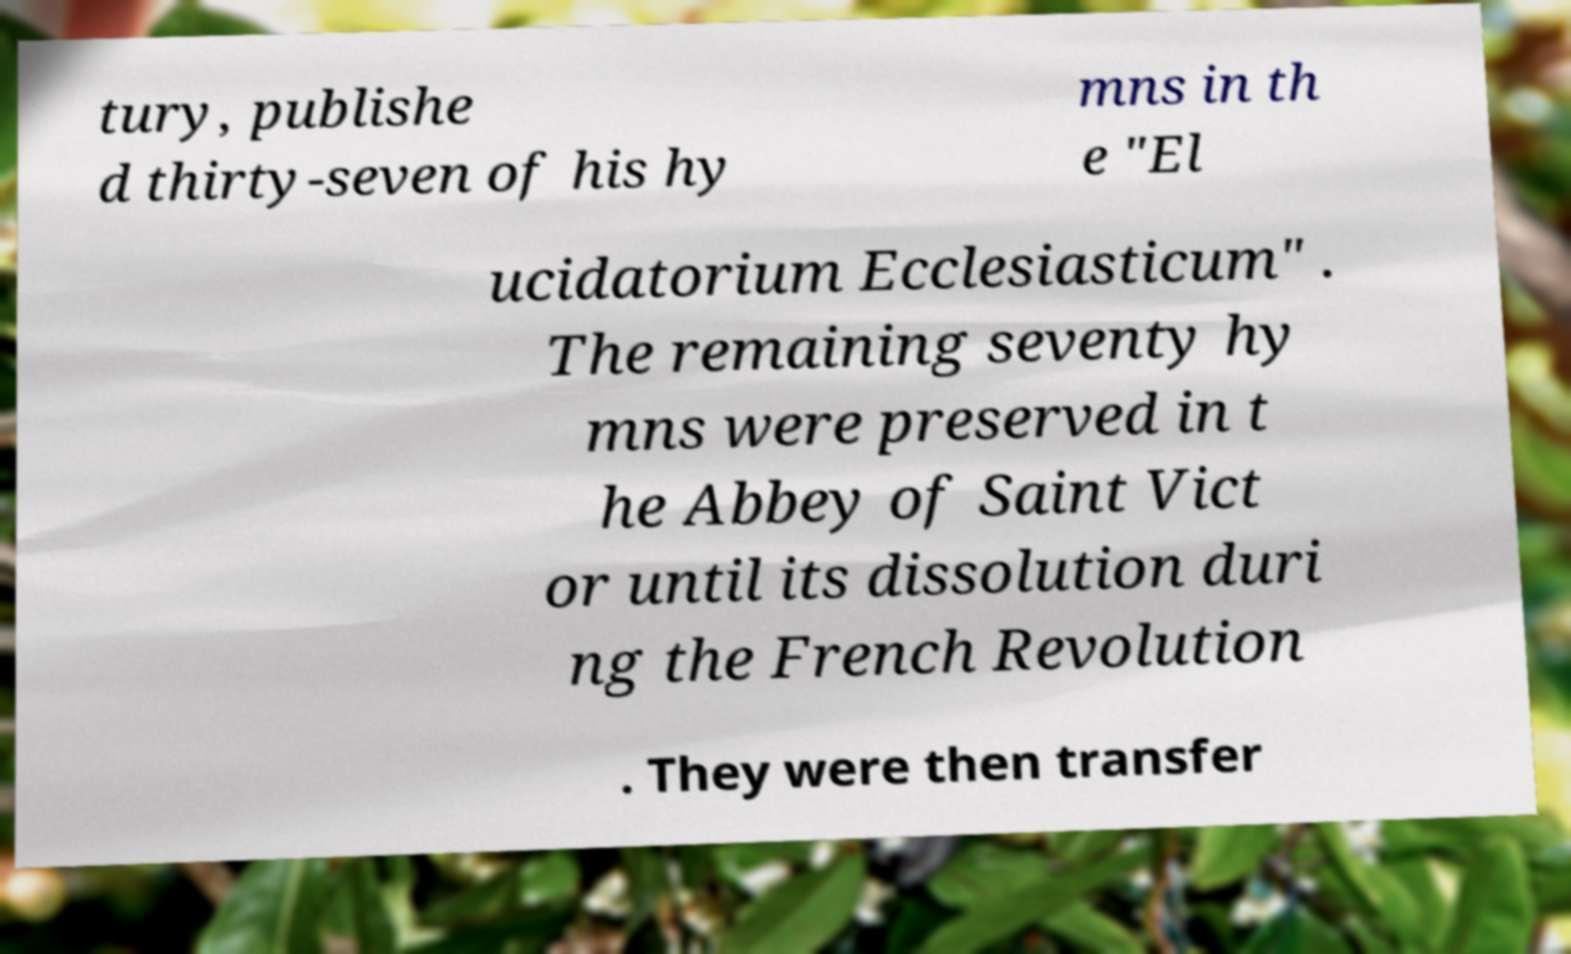Can you accurately transcribe the text from the provided image for me? tury, publishe d thirty-seven of his hy mns in th e "El ucidatorium Ecclesiasticum" . The remaining seventy hy mns were preserved in t he Abbey of Saint Vict or until its dissolution duri ng the French Revolution . They were then transfer 